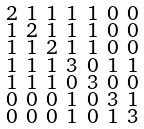Convert formula to latex. <formula><loc_0><loc_0><loc_500><loc_500>\begin{smallmatrix} 2 & 1 & 1 & 1 & 1 & 0 & 0 \\ 1 & 2 & 1 & 1 & 1 & 0 & 0 \\ 1 & 1 & 2 & 1 & 1 & 0 & 0 \\ 1 & 1 & 1 & 3 & 0 & 1 & 1 \\ 1 & 1 & 1 & 0 & 3 & 0 & 0 \\ 0 & 0 & 0 & 1 & 0 & 3 & 1 \\ 0 & 0 & 0 & 1 & 0 & 1 & 3 \end{smallmatrix}</formula> 